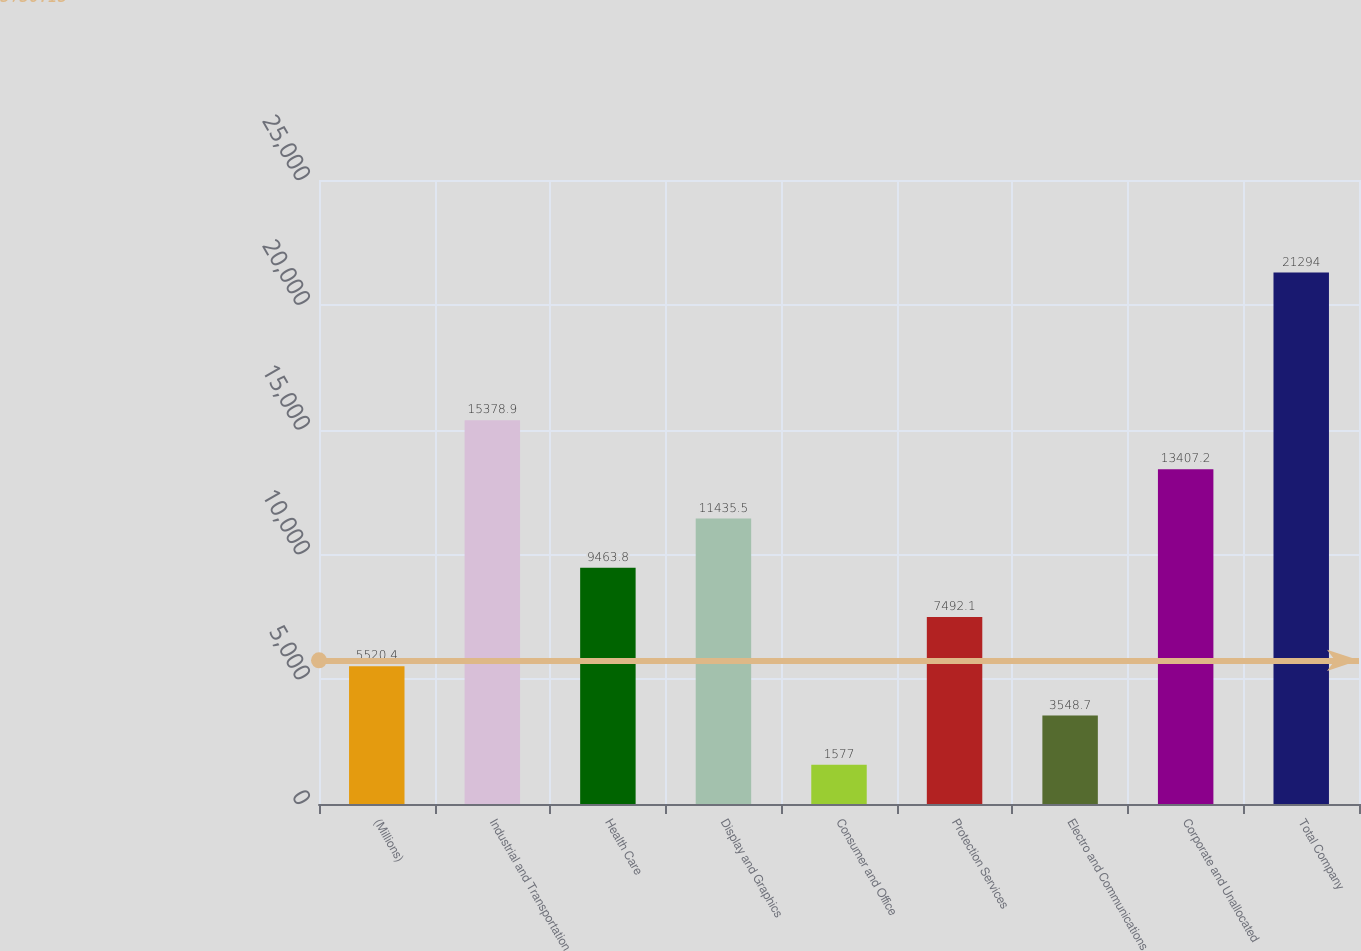Convert chart. <chart><loc_0><loc_0><loc_500><loc_500><bar_chart><fcel>(Millions)<fcel>Industrial and Transportation<fcel>Health Care<fcel>Display and Graphics<fcel>Consumer and Office<fcel>Protection Services<fcel>Electro and Communications<fcel>Corporate and Unallocated<fcel>Total Company<nl><fcel>5520.4<fcel>15378.9<fcel>9463.8<fcel>11435.5<fcel>1577<fcel>7492.1<fcel>3548.7<fcel>13407.2<fcel>21294<nl></chart> 